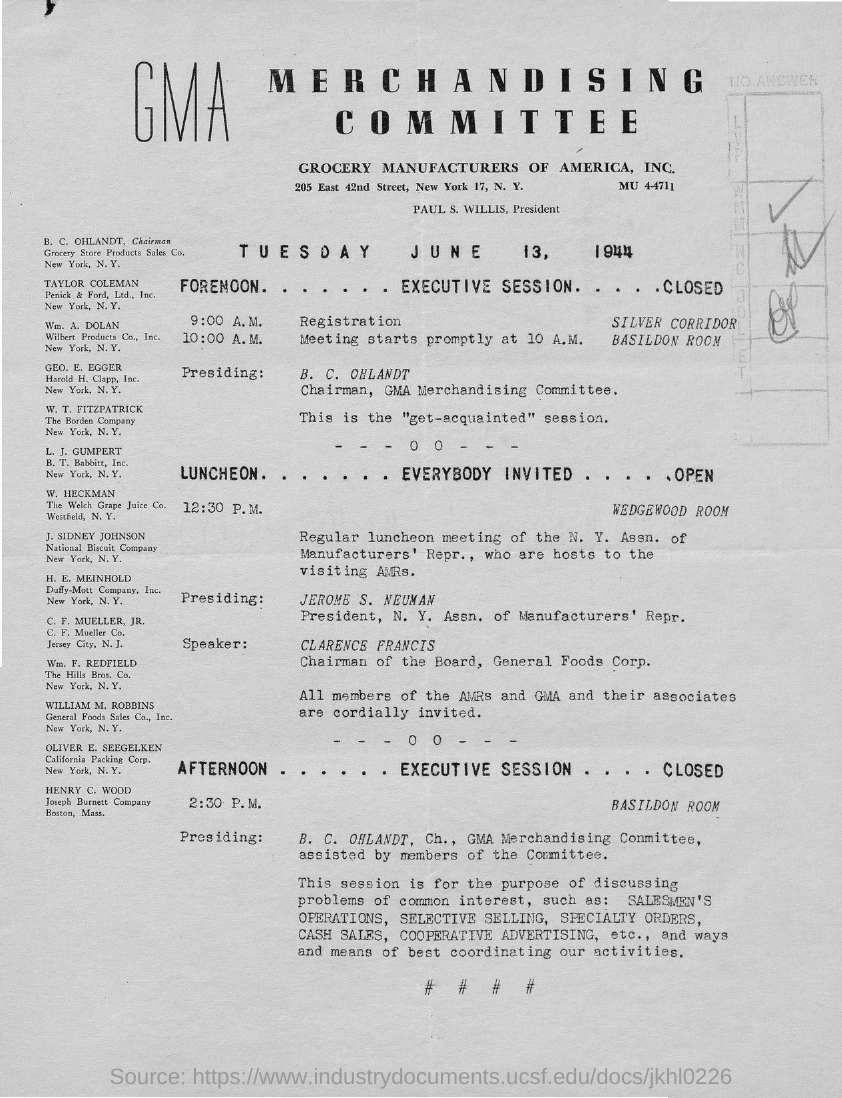Mention a couple of crucial points in this snapshot. The speaker is Clarence Francis. I, CLARENCE FRANCIS, do hereby declare that I am the Chairman of the Board of General Foods Corp. Grocery Store Products Sales Co is located in New York. The heading "MERCHANDISING" mentions a specific committee. The meeting is scheduled to start at 10:00 A.M. 